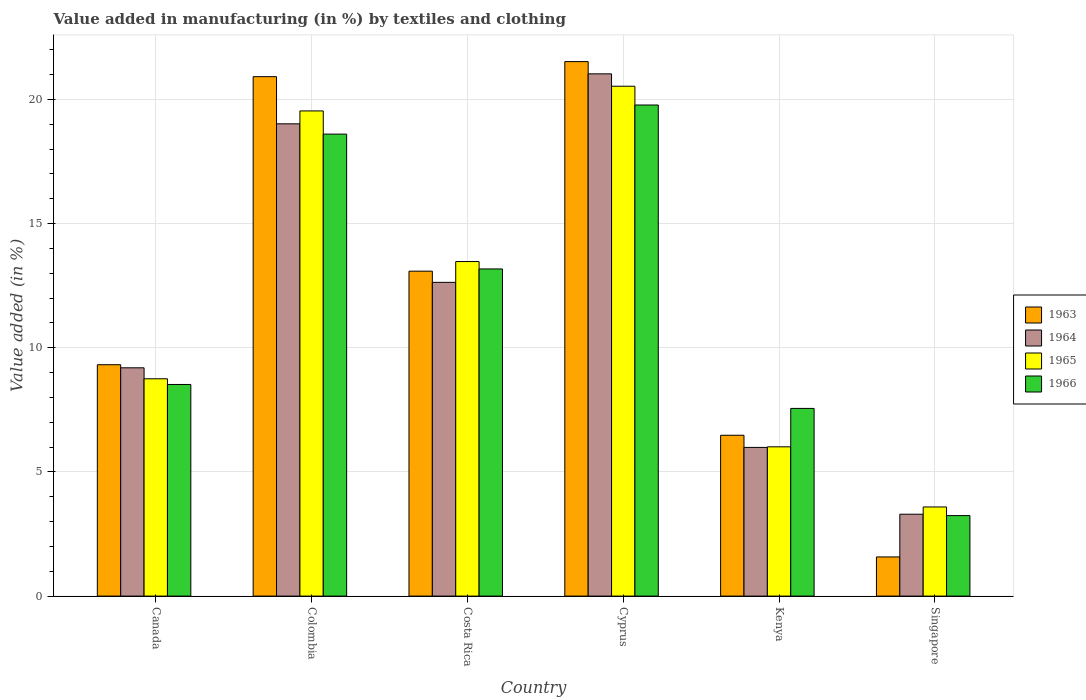How many groups of bars are there?
Provide a short and direct response. 6. Are the number of bars on each tick of the X-axis equal?
Give a very brief answer. Yes. How many bars are there on the 6th tick from the left?
Give a very brief answer. 4. How many bars are there on the 6th tick from the right?
Offer a very short reply. 4. In how many cases, is the number of bars for a given country not equal to the number of legend labels?
Ensure brevity in your answer.  0. What is the percentage of value added in manufacturing by textiles and clothing in 1965 in Colombia?
Your answer should be very brief. 19.54. Across all countries, what is the maximum percentage of value added in manufacturing by textiles and clothing in 1963?
Keep it short and to the point. 21.52. Across all countries, what is the minimum percentage of value added in manufacturing by textiles and clothing in 1963?
Ensure brevity in your answer.  1.58. In which country was the percentage of value added in manufacturing by textiles and clothing in 1963 maximum?
Offer a terse response. Cyprus. In which country was the percentage of value added in manufacturing by textiles and clothing in 1965 minimum?
Ensure brevity in your answer.  Singapore. What is the total percentage of value added in manufacturing by textiles and clothing in 1965 in the graph?
Your response must be concise. 71.89. What is the difference between the percentage of value added in manufacturing by textiles and clothing in 1966 in Cyprus and that in Singapore?
Provide a succinct answer. 16.53. What is the difference between the percentage of value added in manufacturing by textiles and clothing in 1964 in Singapore and the percentage of value added in manufacturing by textiles and clothing in 1966 in Canada?
Your response must be concise. -5.22. What is the average percentage of value added in manufacturing by textiles and clothing in 1965 per country?
Provide a short and direct response. 11.98. What is the difference between the percentage of value added in manufacturing by textiles and clothing of/in 1966 and percentage of value added in manufacturing by textiles and clothing of/in 1963 in Colombia?
Keep it short and to the point. -2.31. What is the ratio of the percentage of value added in manufacturing by textiles and clothing in 1966 in Colombia to that in Kenya?
Keep it short and to the point. 2.46. What is the difference between the highest and the second highest percentage of value added in manufacturing by textiles and clothing in 1964?
Your answer should be compact. 6.38. What is the difference between the highest and the lowest percentage of value added in manufacturing by textiles and clothing in 1964?
Offer a very short reply. 17.73. Is the sum of the percentage of value added in manufacturing by textiles and clothing in 1965 in Canada and Kenya greater than the maximum percentage of value added in manufacturing by textiles and clothing in 1966 across all countries?
Provide a succinct answer. No. Is it the case that in every country, the sum of the percentage of value added in manufacturing by textiles and clothing in 1965 and percentage of value added in manufacturing by textiles and clothing in 1966 is greater than the sum of percentage of value added in manufacturing by textiles and clothing in 1964 and percentage of value added in manufacturing by textiles and clothing in 1963?
Your answer should be very brief. No. What does the 1st bar from the left in Costa Rica represents?
Offer a very short reply. 1963. What does the 2nd bar from the right in Cyprus represents?
Make the answer very short. 1965. Is it the case that in every country, the sum of the percentage of value added in manufacturing by textiles and clothing in 1963 and percentage of value added in manufacturing by textiles and clothing in 1964 is greater than the percentage of value added in manufacturing by textiles and clothing in 1966?
Provide a succinct answer. Yes. Are all the bars in the graph horizontal?
Provide a succinct answer. No. How many countries are there in the graph?
Give a very brief answer. 6. What is the difference between two consecutive major ticks on the Y-axis?
Keep it short and to the point. 5. Are the values on the major ticks of Y-axis written in scientific E-notation?
Keep it short and to the point. No. Does the graph contain grids?
Offer a terse response. Yes. How are the legend labels stacked?
Your response must be concise. Vertical. What is the title of the graph?
Ensure brevity in your answer.  Value added in manufacturing (in %) by textiles and clothing. What is the label or title of the Y-axis?
Provide a short and direct response. Value added (in %). What is the Value added (in %) in 1963 in Canada?
Keep it short and to the point. 9.32. What is the Value added (in %) in 1964 in Canada?
Offer a very short reply. 9.19. What is the Value added (in %) in 1965 in Canada?
Offer a terse response. 8.75. What is the Value added (in %) of 1966 in Canada?
Provide a succinct answer. 8.52. What is the Value added (in %) in 1963 in Colombia?
Keep it short and to the point. 20.92. What is the Value added (in %) in 1964 in Colombia?
Offer a very short reply. 19.02. What is the Value added (in %) of 1965 in Colombia?
Your answer should be very brief. 19.54. What is the Value added (in %) of 1966 in Colombia?
Give a very brief answer. 18.6. What is the Value added (in %) of 1963 in Costa Rica?
Make the answer very short. 13.08. What is the Value added (in %) of 1964 in Costa Rica?
Keep it short and to the point. 12.63. What is the Value added (in %) in 1965 in Costa Rica?
Make the answer very short. 13.47. What is the Value added (in %) in 1966 in Costa Rica?
Offer a terse response. 13.17. What is the Value added (in %) in 1963 in Cyprus?
Offer a very short reply. 21.52. What is the Value added (in %) in 1964 in Cyprus?
Provide a succinct answer. 21.03. What is the Value added (in %) in 1965 in Cyprus?
Keep it short and to the point. 20.53. What is the Value added (in %) in 1966 in Cyprus?
Provide a succinct answer. 19.78. What is the Value added (in %) of 1963 in Kenya?
Your response must be concise. 6.48. What is the Value added (in %) in 1964 in Kenya?
Keep it short and to the point. 5.99. What is the Value added (in %) of 1965 in Kenya?
Ensure brevity in your answer.  6.01. What is the Value added (in %) of 1966 in Kenya?
Make the answer very short. 7.56. What is the Value added (in %) in 1963 in Singapore?
Provide a succinct answer. 1.58. What is the Value added (in %) of 1964 in Singapore?
Your answer should be very brief. 3.3. What is the Value added (in %) of 1965 in Singapore?
Give a very brief answer. 3.59. What is the Value added (in %) in 1966 in Singapore?
Your answer should be compact. 3.24. Across all countries, what is the maximum Value added (in %) in 1963?
Ensure brevity in your answer.  21.52. Across all countries, what is the maximum Value added (in %) of 1964?
Give a very brief answer. 21.03. Across all countries, what is the maximum Value added (in %) in 1965?
Give a very brief answer. 20.53. Across all countries, what is the maximum Value added (in %) in 1966?
Make the answer very short. 19.78. Across all countries, what is the minimum Value added (in %) in 1963?
Keep it short and to the point. 1.58. Across all countries, what is the minimum Value added (in %) in 1964?
Provide a succinct answer. 3.3. Across all countries, what is the minimum Value added (in %) of 1965?
Offer a terse response. 3.59. Across all countries, what is the minimum Value added (in %) in 1966?
Your answer should be compact. 3.24. What is the total Value added (in %) in 1963 in the graph?
Provide a short and direct response. 72.9. What is the total Value added (in %) in 1964 in the graph?
Provide a succinct answer. 71.16. What is the total Value added (in %) in 1965 in the graph?
Ensure brevity in your answer.  71.89. What is the total Value added (in %) of 1966 in the graph?
Give a very brief answer. 70.87. What is the difference between the Value added (in %) in 1963 in Canada and that in Colombia?
Provide a succinct answer. -11.6. What is the difference between the Value added (in %) of 1964 in Canada and that in Colombia?
Your answer should be compact. -9.82. What is the difference between the Value added (in %) in 1965 in Canada and that in Colombia?
Offer a terse response. -10.79. What is the difference between the Value added (in %) of 1966 in Canada and that in Colombia?
Your response must be concise. -10.08. What is the difference between the Value added (in %) in 1963 in Canada and that in Costa Rica?
Your answer should be compact. -3.77. What is the difference between the Value added (in %) in 1964 in Canada and that in Costa Rica?
Provide a succinct answer. -3.44. What is the difference between the Value added (in %) in 1965 in Canada and that in Costa Rica?
Your response must be concise. -4.72. What is the difference between the Value added (in %) of 1966 in Canada and that in Costa Rica?
Your answer should be compact. -4.65. What is the difference between the Value added (in %) in 1963 in Canada and that in Cyprus?
Your response must be concise. -12.21. What is the difference between the Value added (in %) of 1964 in Canada and that in Cyprus?
Provide a short and direct response. -11.84. What is the difference between the Value added (in %) in 1965 in Canada and that in Cyprus?
Provide a short and direct response. -11.78. What is the difference between the Value added (in %) of 1966 in Canada and that in Cyprus?
Make the answer very short. -11.25. What is the difference between the Value added (in %) in 1963 in Canada and that in Kenya?
Your answer should be compact. 2.84. What is the difference between the Value added (in %) in 1964 in Canada and that in Kenya?
Your response must be concise. 3.21. What is the difference between the Value added (in %) in 1965 in Canada and that in Kenya?
Offer a terse response. 2.74. What is the difference between the Value added (in %) in 1966 in Canada and that in Kenya?
Make the answer very short. 0.96. What is the difference between the Value added (in %) in 1963 in Canada and that in Singapore?
Your answer should be very brief. 7.74. What is the difference between the Value added (in %) of 1964 in Canada and that in Singapore?
Provide a succinct answer. 5.9. What is the difference between the Value added (in %) in 1965 in Canada and that in Singapore?
Your answer should be compact. 5.16. What is the difference between the Value added (in %) in 1966 in Canada and that in Singapore?
Offer a very short reply. 5.28. What is the difference between the Value added (in %) in 1963 in Colombia and that in Costa Rica?
Your answer should be very brief. 7.83. What is the difference between the Value added (in %) in 1964 in Colombia and that in Costa Rica?
Offer a terse response. 6.38. What is the difference between the Value added (in %) of 1965 in Colombia and that in Costa Rica?
Provide a short and direct response. 6.06. What is the difference between the Value added (in %) of 1966 in Colombia and that in Costa Rica?
Your answer should be very brief. 5.43. What is the difference between the Value added (in %) of 1963 in Colombia and that in Cyprus?
Offer a very short reply. -0.61. What is the difference between the Value added (in %) of 1964 in Colombia and that in Cyprus?
Offer a very short reply. -2.01. What is the difference between the Value added (in %) of 1965 in Colombia and that in Cyprus?
Provide a short and direct response. -0.99. What is the difference between the Value added (in %) in 1966 in Colombia and that in Cyprus?
Provide a short and direct response. -1.17. What is the difference between the Value added (in %) in 1963 in Colombia and that in Kenya?
Give a very brief answer. 14.44. What is the difference between the Value added (in %) of 1964 in Colombia and that in Kenya?
Offer a terse response. 13.03. What is the difference between the Value added (in %) in 1965 in Colombia and that in Kenya?
Keep it short and to the point. 13.53. What is the difference between the Value added (in %) in 1966 in Colombia and that in Kenya?
Make the answer very short. 11.05. What is the difference between the Value added (in %) in 1963 in Colombia and that in Singapore?
Offer a very short reply. 19.34. What is the difference between the Value added (in %) in 1964 in Colombia and that in Singapore?
Your response must be concise. 15.72. What is the difference between the Value added (in %) in 1965 in Colombia and that in Singapore?
Ensure brevity in your answer.  15.95. What is the difference between the Value added (in %) in 1966 in Colombia and that in Singapore?
Offer a terse response. 15.36. What is the difference between the Value added (in %) in 1963 in Costa Rica and that in Cyprus?
Your response must be concise. -8.44. What is the difference between the Value added (in %) in 1964 in Costa Rica and that in Cyprus?
Give a very brief answer. -8.4. What is the difference between the Value added (in %) in 1965 in Costa Rica and that in Cyprus?
Your response must be concise. -7.06. What is the difference between the Value added (in %) in 1966 in Costa Rica and that in Cyprus?
Make the answer very short. -6.6. What is the difference between the Value added (in %) in 1963 in Costa Rica and that in Kenya?
Provide a short and direct response. 6.61. What is the difference between the Value added (in %) in 1964 in Costa Rica and that in Kenya?
Your answer should be very brief. 6.65. What is the difference between the Value added (in %) of 1965 in Costa Rica and that in Kenya?
Make the answer very short. 7.46. What is the difference between the Value added (in %) of 1966 in Costa Rica and that in Kenya?
Your response must be concise. 5.62. What is the difference between the Value added (in %) in 1963 in Costa Rica and that in Singapore?
Your answer should be very brief. 11.51. What is the difference between the Value added (in %) in 1964 in Costa Rica and that in Singapore?
Your answer should be very brief. 9.34. What is the difference between the Value added (in %) of 1965 in Costa Rica and that in Singapore?
Ensure brevity in your answer.  9.88. What is the difference between the Value added (in %) of 1966 in Costa Rica and that in Singapore?
Give a very brief answer. 9.93. What is the difference between the Value added (in %) of 1963 in Cyprus and that in Kenya?
Your answer should be very brief. 15.05. What is the difference between the Value added (in %) of 1964 in Cyprus and that in Kenya?
Give a very brief answer. 15.04. What is the difference between the Value added (in %) of 1965 in Cyprus and that in Kenya?
Your answer should be compact. 14.52. What is the difference between the Value added (in %) of 1966 in Cyprus and that in Kenya?
Offer a terse response. 12.22. What is the difference between the Value added (in %) of 1963 in Cyprus and that in Singapore?
Provide a succinct answer. 19.95. What is the difference between the Value added (in %) of 1964 in Cyprus and that in Singapore?
Ensure brevity in your answer.  17.73. What is the difference between the Value added (in %) of 1965 in Cyprus and that in Singapore?
Your response must be concise. 16.94. What is the difference between the Value added (in %) in 1966 in Cyprus and that in Singapore?
Provide a succinct answer. 16.53. What is the difference between the Value added (in %) of 1963 in Kenya and that in Singapore?
Provide a succinct answer. 4.9. What is the difference between the Value added (in %) of 1964 in Kenya and that in Singapore?
Your answer should be very brief. 2.69. What is the difference between the Value added (in %) of 1965 in Kenya and that in Singapore?
Your answer should be compact. 2.42. What is the difference between the Value added (in %) in 1966 in Kenya and that in Singapore?
Give a very brief answer. 4.32. What is the difference between the Value added (in %) in 1963 in Canada and the Value added (in %) in 1964 in Colombia?
Ensure brevity in your answer.  -9.7. What is the difference between the Value added (in %) of 1963 in Canada and the Value added (in %) of 1965 in Colombia?
Make the answer very short. -10.22. What is the difference between the Value added (in %) of 1963 in Canada and the Value added (in %) of 1966 in Colombia?
Keep it short and to the point. -9.29. What is the difference between the Value added (in %) in 1964 in Canada and the Value added (in %) in 1965 in Colombia?
Your response must be concise. -10.34. What is the difference between the Value added (in %) of 1964 in Canada and the Value added (in %) of 1966 in Colombia?
Your response must be concise. -9.41. What is the difference between the Value added (in %) of 1965 in Canada and the Value added (in %) of 1966 in Colombia?
Provide a short and direct response. -9.85. What is the difference between the Value added (in %) in 1963 in Canada and the Value added (in %) in 1964 in Costa Rica?
Provide a succinct answer. -3.32. What is the difference between the Value added (in %) in 1963 in Canada and the Value added (in %) in 1965 in Costa Rica?
Provide a short and direct response. -4.16. What is the difference between the Value added (in %) in 1963 in Canada and the Value added (in %) in 1966 in Costa Rica?
Provide a short and direct response. -3.86. What is the difference between the Value added (in %) of 1964 in Canada and the Value added (in %) of 1965 in Costa Rica?
Offer a very short reply. -4.28. What is the difference between the Value added (in %) in 1964 in Canada and the Value added (in %) in 1966 in Costa Rica?
Give a very brief answer. -3.98. What is the difference between the Value added (in %) of 1965 in Canada and the Value added (in %) of 1966 in Costa Rica?
Make the answer very short. -4.42. What is the difference between the Value added (in %) of 1963 in Canada and the Value added (in %) of 1964 in Cyprus?
Your answer should be compact. -11.71. What is the difference between the Value added (in %) in 1963 in Canada and the Value added (in %) in 1965 in Cyprus?
Your response must be concise. -11.21. What is the difference between the Value added (in %) in 1963 in Canada and the Value added (in %) in 1966 in Cyprus?
Provide a short and direct response. -10.46. What is the difference between the Value added (in %) of 1964 in Canada and the Value added (in %) of 1965 in Cyprus?
Provide a short and direct response. -11.34. What is the difference between the Value added (in %) in 1964 in Canada and the Value added (in %) in 1966 in Cyprus?
Offer a very short reply. -10.58. What is the difference between the Value added (in %) in 1965 in Canada and the Value added (in %) in 1966 in Cyprus?
Ensure brevity in your answer.  -11.02. What is the difference between the Value added (in %) of 1963 in Canada and the Value added (in %) of 1964 in Kenya?
Give a very brief answer. 3.33. What is the difference between the Value added (in %) in 1963 in Canada and the Value added (in %) in 1965 in Kenya?
Your response must be concise. 3.31. What is the difference between the Value added (in %) in 1963 in Canada and the Value added (in %) in 1966 in Kenya?
Keep it short and to the point. 1.76. What is the difference between the Value added (in %) of 1964 in Canada and the Value added (in %) of 1965 in Kenya?
Your response must be concise. 3.18. What is the difference between the Value added (in %) of 1964 in Canada and the Value added (in %) of 1966 in Kenya?
Provide a succinct answer. 1.64. What is the difference between the Value added (in %) of 1965 in Canada and the Value added (in %) of 1966 in Kenya?
Provide a succinct answer. 1.19. What is the difference between the Value added (in %) of 1963 in Canada and the Value added (in %) of 1964 in Singapore?
Offer a very short reply. 6.02. What is the difference between the Value added (in %) in 1963 in Canada and the Value added (in %) in 1965 in Singapore?
Your response must be concise. 5.73. What is the difference between the Value added (in %) of 1963 in Canada and the Value added (in %) of 1966 in Singapore?
Provide a short and direct response. 6.08. What is the difference between the Value added (in %) of 1964 in Canada and the Value added (in %) of 1965 in Singapore?
Ensure brevity in your answer.  5.6. What is the difference between the Value added (in %) of 1964 in Canada and the Value added (in %) of 1966 in Singapore?
Offer a terse response. 5.95. What is the difference between the Value added (in %) in 1965 in Canada and the Value added (in %) in 1966 in Singapore?
Provide a succinct answer. 5.51. What is the difference between the Value added (in %) in 1963 in Colombia and the Value added (in %) in 1964 in Costa Rica?
Give a very brief answer. 8.28. What is the difference between the Value added (in %) in 1963 in Colombia and the Value added (in %) in 1965 in Costa Rica?
Your response must be concise. 7.44. What is the difference between the Value added (in %) of 1963 in Colombia and the Value added (in %) of 1966 in Costa Rica?
Offer a terse response. 7.74. What is the difference between the Value added (in %) in 1964 in Colombia and the Value added (in %) in 1965 in Costa Rica?
Provide a succinct answer. 5.55. What is the difference between the Value added (in %) of 1964 in Colombia and the Value added (in %) of 1966 in Costa Rica?
Offer a very short reply. 5.84. What is the difference between the Value added (in %) in 1965 in Colombia and the Value added (in %) in 1966 in Costa Rica?
Give a very brief answer. 6.36. What is the difference between the Value added (in %) of 1963 in Colombia and the Value added (in %) of 1964 in Cyprus?
Your response must be concise. -0.11. What is the difference between the Value added (in %) of 1963 in Colombia and the Value added (in %) of 1965 in Cyprus?
Your response must be concise. 0.39. What is the difference between the Value added (in %) in 1963 in Colombia and the Value added (in %) in 1966 in Cyprus?
Your response must be concise. 1.14. What is the difference between the Value added (in %) in 1964 in Colombia and the Value added (in %) in 1965 in Cyprus?
Give a very brief answer. -1.51. What is the difference between the Value added (in %) in 1964 in Colombia and the Value added (in %) in 1966 in Cyprus?
Offer a terse response. -0.76. What is the difference between the Value added (in %) of 1965 in Colombia and the Value added (in %) of 1966 in Cyprus?
Give a very brief answer. -0.24. What is the difference between the Value added (in %) of 1963 in Colombia and the Value added (in %) of 1964 in Kenya?
Offer a very short reply. 14.93. What is the difference between the Value added (in %) of 1963 in Colombia and the Value added (in %) of 1965 in Kenya?
Provide a succinct answer. 14.91. What is the difference between the Value added (in %) in 1963 in Colombia and the Value added (in %) in 1966 in Kenya?
Offer a terse response. 13.36. What is the difference between the Value added (in %) of 1964 in Colombia and the Value added (in %) of 1965 in Kenya?
Your answer should be very brief. 13.01. What is the difference between the Value added (in %) in 1964 in Colombia and the Value added (in %) in 1966 in Kenya?
Provide a succinct answer. 11.46. What is the difference between the Value added (in %) in 1965 in Colombia and the Value added (in %) in 1966 in Kenya?
Ensure brevity in your answer.  11.98. What is the difference between the Value added (in %) of 1963 in Colombia and the Value added (in %) of 1964 in Singapore?
Offer a very short reply. 17.62. What is the difference between the Value added (in %) of 1963 in Colombia and the Value added (in %) of 1965 in Singapore?
Provide a short and direct response. 17.33. What is the difference between the Value added (in %) in 1963 in Colombia and the Value added (in %) in 1966 in Singapore?
Your response must be concise. 17.68. What is the difference between the Value added (in %) of 1964 in Colombia and the Value added (in %) of 1965 in Singapore?
Your answer should be compact. 15.43. What is the difference between the Value added (in %) in 1964 in Colombia and the Value added (in %) in 1966 in Singapore?
Your answer should be very brief. 15.78. What is the difference between the Value added (in %) of 1965 in Colombia and the Value added (in %) of 1966 in Singapore?
Provide a short and direct response. 16.3. What is the difference between the Value added (in %) of 1963 in Costa Rica and the Value added (in %) of 1964 in Cyprus?
Your response must be concise. -7.95. What is the difference between the Value added (in %) of 1963 in Costa Rica and the Value added (in %) of 1965 in Cyprus?
Give a very brief answer. -7.45. What is the difference between the Value added (in %) in 1963 in Costa Rica and the Value added (in %) in 1966 in Cyprus?
Make the answer very short. -6.69. What is the difference between the Value added (in %) in 1964 in Costa Rica and the Value added (in %) in 1965 in Cyprus?
Ensure brevity in your answer.  -7.9. What is the difference between the Value added (in %) in 1964 in Costa Rica and the Value added (in %) in 1966 in Cyprus?
Provide a short and direct response. -7.14. What is the difference between the Value added (in %) in 1965 in Costa Rica and the Value added (in %) in 1966 in Cyprus?
Keep it short and to the point. -6.3. What is the difference between the Value added (in %) in 1963 in Costa Rica and the Value added (in %) in 1964 in Kenya?
Give a very brief answer. 7.1. What is the difference between the Value added (in %) of 1963 in Costa Rica and the Value added (in %) of 1965 in Kenya?
Your response must be concise. 7.07. What is the difference between the Value added (in %) of 1963 in Costa Rica and the Value added (in %) of 1966 in Kenya?
Provide a succinct answer. 5.53. What is the difference between the Value added (in %) in 1964 in Costa Rica and the Value added (in %) in 1965 in Kenya?
Provide a succinct answer. 6.62. What is the difference between the Value added (in %) of 1964 in Costa Rica and the Value added (in %) of 1966 in Kenya?
Make the answer very short. 5.08. What is the difference between the Value added (in %) in 1965 in Costa Rica and the Value added (in %) in 1966 in Kenya?
Your answer should be compact. 5.91. What is the difference between the Value added (in %) of 1963 in Costa Rica and the Value added (in %) of 1964 in Singapore?
Keep it short and to the point. 9.79. What is the difference between the Value added (in %) in 1963 in Costa Rica and the Value added (in %) in 1965 in Singapore?
Your answer should be compact. 9.5. What is the difference between the Value added (in %) of 1963 in Costa Rica and the Value added (in %) of 1966 in Singapore?
Offer a very short reply. 9.84. What is the difference between the Value added (in %) in 1964 in Costa Rica and the Value added (in %) in 1965 in Singapore?
Your response must be concise. 9.04. What is the difference between the Value added (in %) in 1964 in Costa Rica and the Value added (in %) in 1966 in Singapore?
Offer a terse response. 9.39. What is the difference between the Value added (in %) in 1965 in Costa Rica and the Value added (in %) in 1966 in Singapore?
Keep it short and to the point. 10.23. What is the difference between the Value added (in %) of 1963 in Cyprus and the Value added (in %) of 1964 in Kenya?
Ensure brevity in your answer.  15.54. What is the difference between the Value added (in %) of 1963 in Cyprus and the Value added (in %) of 1965 in Kenya?
Your answer should be compact. 15.51. What is the difference between the Value added (in %) of 1963 in Cyprus and the Value added (in %) of 1966 in Kenya?
Your answer should be compact. 13.97. What is the difference between the Value added (in %) in 1964 in Cyprus and the Value added (in %) in 1965 in Kenya?
Your response must be concise. 15.02. What is the difference between the Value added (in %) in 1964 in Cyprus and the Value added (in %) in 1966 in Kenya?
Provide a short and direct response. 13.47. What is the difference between the Value added (in %) of 1965 in Cyprus and the Value added (in %) of 1966 in Kenya?
Make the answer very short. 12.97. What is the difference between the Value added (in %) in 1963 in Cyprus and the Value added (in %) in 1964 in Singapore?
Provide a succinct answer. 18.23. What is the difference between the Value added (in %) of 1963 in Cyprus and the Value added (in %) of 1965 in Singapore?
Make the answer very short. 17.93. What is the difference between the Value added (in %) in 1963 in Cyprus and the Value added (in %) in 1966 in Singapore?
Your answer should be compact. 18.28. What is the difference between the Value added (in %) in 1964 in Cyprus and the Value added (in %) in 1965 in Singapore?
Provide a succinct answer. 17.44. What is the difference between the Value added (in %) in 1964 in Cyprus and the Value added (in %) in 1966 in Singapore?
Ensure brevity in your answer.  17.79. What is the difference between the Value added (in %) of 1965 in Cyprus and the Value added (in %) of 1966 in Singapore?
Your answer should be compact. 17.29. What is the difference between the Value added (in %) in 1963 in Kenya and the Value added (in %) in 1964 in Singapore?
Provide a short and direct response. 3.18. What is the difference between the Value added (in %) in 1963 in Kenya and the Value added (in %) in 1965 in Singapore?
Your answer should be very brief. 2.89. What is the difference between the Value added (in %) in 1963 in Kenya and the Value added (in %) in 1966 in Singapore?
Make the answer very short. 3.24. What is the difference between the Value added (in %) in 1964 in Kenya and the Value added (in %) in 1965 in Singapore?
Give a very brief answer. 2.4. What is the difference between the Value added (in %) in 1964 in Kenya and the Value added (in %) in 1966 in Singapore?
Offer a very short reply. 2.75. What is the difference between the Value added (in %) in 1965 in Kenya and the Value added (in %) in 1966 in Singapore?
Give a very brief answer. 2.77. What is the average Value added (in %) of 1963 per country?
Ensure brevity in your answer.  12.15. What is the average Value added (in %) in 1964 per country?
Provide a short and direct response. 11.86. What is the average Value added (in %) in 1965 per country?
Ensure brevity in your answer.  11.98. What is the average Value added (in %) of 1966 per country?
Give a very brief answer. 11.81. What is the difference between the Value added (in %) in 1963 and Value added (in %) in 1964 in Canada?
Make the answer very short. 0.12. What is the difference between the Value added (in %) in 1963 and Value added (in %) in 1965 in Canada?
Your response must be concise. 0.57. What is the difference between the Value added (in %) in 1963 and Value added (in %) in 1966 in Canada?
Make the answer very short. 0.8. What is the difference between the Value added (in %) of 1964 and Value added (in %) of 1965 in Canada?
Offer a terse response. 0.44. What is the difference between the Value added (in %) in 1964 and Value added (in %) in 1966 in Canada?
Keep it short and to the point. 0.67. What is the difference between the Value added (in %) in 1965 and Value added (in %) in 1966 in Canada?
Your answer should be very brief. 0.23. What is the difference between the Value added (in %) in 1963 and Value added (in %) in 1964 in Colombia?
Offer a very short reply. 1.9. What is the difference between the Value added (in %) in 1963 and Value added (in %) in 1965 in Colombia?
Offer a terse response. 1.38. What is the difference between the Value added (in %) of 1963 and Value added (in %) of 1966 in Colombia?
Provide a succinct answer. 2.31. What is the difference between the Value added (in %) of 1964 and Value added (in %) of 1965 in Colombia?
Your answer should be compact. -0.52. What is the difference between the Value added (in %) in 1964 and Value added (in %) in 1966 in Colombia?
Keep it short and to the point. 0.41. What is the difference between the Value added (in %) in 1965 and Value added (in %) in 1966 in Colombia?
Provide a short and direct response. 0.93. What is the difference between the Value added (in %) of 1963 and Value added (in %) of 1964 in Costa Rica?
Provide a short and direct response. 0.45. What is the difference between the Value added (in %) of 1963 and Value added (in %) of 1965 in Costa Rica?
Your answer should be compact. -0.39. What is the difference between the Value added (in %) in 1963 and Value added (in %) in 1966 in Costa Rica?
Your response must be concise. -0.09. What is the difference between the Value added (in %) of 1964 and Value added (in %) of 1965 in Costa Rica?
Your answer should be compact. -0.84. What is the difference between the Value added (in %) in 1964 and Value added (in %) in 1966 in Costa Rica?
Your answer should be compact. -0.54. What is the difference between the Value added (in %) in 1965 and Value added (in %) in 1966 in Costa Rica?
Keep it short and to the point. 0.3. What is the difference between the Value added (in %) of 1963 and Value added (in %) of 1964 in Cyprus?
Give a very brief answer. 0.49. What is the difference between the Value added (in %) of 1963 and Value added (in %) of 1965 in Cyprus?
Your answer should be very brief. 0.99. What is the difference between the Value added (in %) of 1963 and Value added (in %) of 1966 in Cyprus?
Your response must be concise. 1.75. What is the difference between the Value added (in %) in 1964 and Value added (in %) in 1965 in Cyprus?
Offer a very short reply. 0.5. What is the difference between the Value added (in %) in 1964 and Value added (in %) in 1966 in Cyprus?
Give a very brief answer. 1.25. What is the difference between the Value added (in %) in 1965 and Value added (in %) in 1966 in Cyprus?
Keep it short and to the point. 0.76. What is the difference between the Value added (in %) in 1963 and Value added (in %) in 1964 in Kenya?
Offer a very short reply. 0.49. What is the difference between the Value added (in %) in 1963 and Value added (in %) in 1965 in Kenya?
Offer a terse response. 0.47. What is the difference between the Value added (in %) of 1963 and Value added (in %) of 1966 in Kenya?
Provide a short and direct response. -1.08. What is the difference between the Value added (in %) in 1964 and Value added (in %) in 1965 in Kenya?
Provide a short and direct response. -0.02. What is the difference between the Value added (in %) in 1964 and Value added (in %) in 1966 in Kenya?
Offer a very short reply. -1.57. What is the difference between the Value added (in %) in 1965 and Value added (in %) in 1966 in Kenya?
Provide a succinct answer. -1.55. What is the difference between the Value added (in %) in 1963 and Value added (in %) in 1964 in Singapore?
Offer a very short reply. -1.72. What is the difference between the Value added (in %) in 1963 and Value added (in %) in 1965 in Singapore?
Provide a succinct answer. -2.01. What is the difference between the Value added (in %) of 1963 and Value added (in %) of 1966 in Singapore?
Offer a terse response. -1.66. What is the difference between the Value added (in %) in 1964 and Value added (in %) in 1965 in Singapore?
Give a very brief answer. -0.29. What is the difference between the Value added (in %) of 1964 and Value added (in %) of 1966 in Singapore?
Your answer should be very brief. 0.06. What is the difference between the Value added (in %) in 1965 and Value added (in %) in 1966 in Singapore?
Provide a short and direct response. 0.35. What is the ratio of the Value added (in %) in 1963 in Canada to that in Colombia?
Make the answer very short. 0.45. What is the ratio of the Value added (in %) in 1964 in Canada to that in Colombia?
Your answer should be very brief. 0.48. What is the ratio of the Value added (in %) of 1965 in Canada to that in Colombia?
Your answer should be very brief. 0.45. What is the ratio of the Value added (in %) in 1966 in Canada to that in Colombia?
Provide a succinct answer. 0.46. What is the ratio of the Value added (in %) of 1963 in Canada to that in Costa Rica?
Your answer should be very brief. 0.71. What is the ratio of the Value added (in %) of 1964 in Canada to that in Costa Rica?
Provide a succinct answer. 0.73. What is the ratio of the Value added (in %) in 1965 in Canada to that in Costa Rica?
Offer a very short reply. 0.65. What is the ratio of the Value added (in %) of 1966 in Canada to that in Costa Rica?
Your response must be concise. 0.65. What is the ratio of the Value added (in %) of 1963 in Canada to that in Cyprus?
Ensure brevity in your answer.  0.43. What is the ratio of the Value added (in %) in 1964 in Canada to that in Cyprus?
Offer a terse response. 0.44. What is the ratio of the Value added (in %) in 1965 in Canada to that in Cyprus?
Make the answer very short. 0.43. What is the ratio of the Value added (in %) in 1966 in Canada to that in Cyprus?
Provide a succinct answer. 0.43. What is the ratio of the Value added (in %) in 1963 in Canada to that in Kenya?
Give a very brief answer. 1.44. What is the ratio of the Value added (in %) of 1964 in Canada to that in Kenya?
Give a very brief answer. 1.54. What is the ratio of the Value added (in %) of 1965 in Canada to that in Kenya?
Keep it short and to the point. 1.46. What is the ratio of the Value added (in %) of 1966 in Canada to that in Kenya?
Offer a very short reply. 1.13. What is the ratio of the Value added (in %) in 1963 in Canada to that in Singapore?
Your answer should be very brief. 5.91. What is the ratio of the Value added (in %) in 1964 in Canada to that in Singapore?
Give a very brief answer. 2.79. What is the ratio of the Value added (in %) in 1965 in Canada to that in Singapore?
Your response must be concise. 2.44. What is the ratio of the Value added (in %) of 1966 in Canada to that in Singapore?
Ensure brevity in your answer.  2.63. What is the ratio of the Value added (in %) of 1963 in Colombia to that in Costa Rica?
Provide a succinct answer. 1.6. What is the ratio of the Value added (in %) of 1964 in Colombia to that in Costa Rica?
Offer a terse response. 1.51. What is the ratio of the Value added (in %) of 1965 in Colombia to that in Costa Rica?
Your answer should be very brief. 1.45. What is the ratio of the Value added (in %) in 1966 in Colombia to that in Costa Rica?
Give a very brief answer. 1.41. What is the ratio of the Value added (in %) of 1963 in Colombia to that in Cyprus?
Offer a very short reply. 0.97. What is the ratio of the Value added (in %) of 1964 in Colombia to that in Cyprus?
Give a very brief answer. 0.9. What is the ratio of the Value added (in %) in 1965 in Colombia to that in Cyprus?
Your answer should be very brief. 0.95. What is the ratio of the Value added (in %) in 1966 in Colombia to that in Cyprus?
Keep it short and to the point. 0.94. What is the ratio of the Value added (in %) of 1963 in Colombia to that in Kenya?
Offer a very short reply. 3.23. What is the ratio of the Value added (in %) of 1964 in Colombia to that in Kenya?
Your answer should be very brief. 3.18. What is the ratio of the Value added (in %) of 1965 in Colombia to that in Kenya?
Provide a short and direct response. 3.25. What is the ratio of the Value added (in %) of 1966 in Colombia to that in Kenya?
Offer a very short reply. 2.46. What is the ratio of the Value added (in %) in 1963 in Colombia to that in Singapore?
Make the answer very short. 13.26. What is the ratio of the Value added (in %) in 1964 in Colombia to that in Singapore?
Make the answer very short. 5.77. What is the ratio of the Value added (in %) in 1965 in Colombia to that in Singapore?
Give a very brief answer. 5.44. What is the ratio of the Value added (in %) of 1966 in Colombia to that in Singapore?
Your answer should be very brief. 5.74. What is the ratio of the Value added (in %) of 1963 in Costa Rica to that in Cyprus?
Ensure brevity in your answer.  0.61. What is the ratio of the Value added (in %) in 1964 in Costa Rica to that in Cyprus?
Your answer should be very brief. 0.6. What is the ratio of the Value added (in %) in 1965 in Costa Rica to that in Cyprus?
Provide a short and direct response. 0.66. What is the ratio of the Value added (in %) of 1966 in Costa Rica to that in Cyprus?
Your answer should be compact. 0.67. What is the ratio of the Value added (in %) in 1963 in Costa Rica to that in Kenya?
Ensure brevity in your answer.  2.02. What is the ratio of the Value added (in %) in 1964 in Costa Rica to that in Kenya?
Keep it short and to the point. 2.11. What is the ratio of the Value added (in %) in 1965 in Costa Rica to that in Kenya?
Provide a succinct answer. 2.24. What is the ratio of the Value added (in %) of 1966 in Costa Rica to that in Kenya?
Make the answer very short. 1.74. What is the ratio of the Value added (in %) of 1963 in Costa Rica to that in Singapore?
Your answer should be compact. 8.3. What is the ratio of the Value added (in %) of 1964 in Costa Rica to that in Singapore?
Make the answer very short. 3.83. What is the ratio of the Value added (in %) of 1965 in Costa Rica to that in Singapore?
Provide a succinct answer. 3.75. What is the ratio of the Value added (in %) of 1966 in Costa Rica to that in Singapore?
Your answer should be very brief. 4.06. What is the ratio of the Value added (in %) in 1963 in Cyprus to that in Kenya?
Your answer should be compact. 3.32. What is the ratio of the Value added (in %) in 1964 in Cyprus to that in Kenya?
Provide a short and direct response. 3.51. What is the ratio of the Value added (in %) of 1965 in Cyprus to that in Kenya?
Give a very brief answer. 3.42. What is the ratio of the Value added (in %) of 1966 in Cyprus to that in Kenya?
Offer a terse response. 2.62. What is the ratio of the Value added (in %) of 1963 in Cyprus to that in Singapore?
Ensure brevity in your answer.  13.65. What is the ratio of the Value added (in %) in 1964 in Cyprus to that in Singapore?
Offer a terse response. 6.38. What is the ratio of the Value added (in %) of 1965 in Cyprus to that in Singapore?
Your answer should be compact. 5.72. What is the ratio of the Value added (in %) in 1966 in Cyprus to that in Singapore?
Your answer should be compact. 6.1. What is the ratio of the Value added (in %) in 1963 in Kenya to that in Singapore?
Give a very brief answer. 4.11. What is the ratio of the Value added (in %) in 1964 in Kenya to that in Singapore?
Keep it short and to the point. 1.82. What is the ratio of the Value added (in %) of 1965 in Kenya to that in Singapore?
Give a very brief answer. 1.67. What is the ratio of the Value added (in %) of 1966 in Kenya to that in Singapore?
Your response must be concise. 2.33. What is the difference between the highest and the second highest Value added (in %) in 1963?
Your response must be concise. 0.61. What is the difference between the highest and the second highest Value added (in %) of 1964?
Offer a terse response. 2.01. What is the difference between the highest and the second highest Value added (in %) of 1966?
Give a very brief answer. 1.17. What is the difference between the highest and the lowest Value added (in %) of 1963?
Make the answer very short. 19.95. What is the difference between the highest and the lowest Value added (in %) of 1964?
Make the answer very short. 17.73. What is the difference between the highest and the lowest Value added (in %) in 1965?
Keep it short and to the point. 16.94. What is the difference between the highest and the lowest Value added (in %) in 1966?
Give a very brief answer. 16.53. 